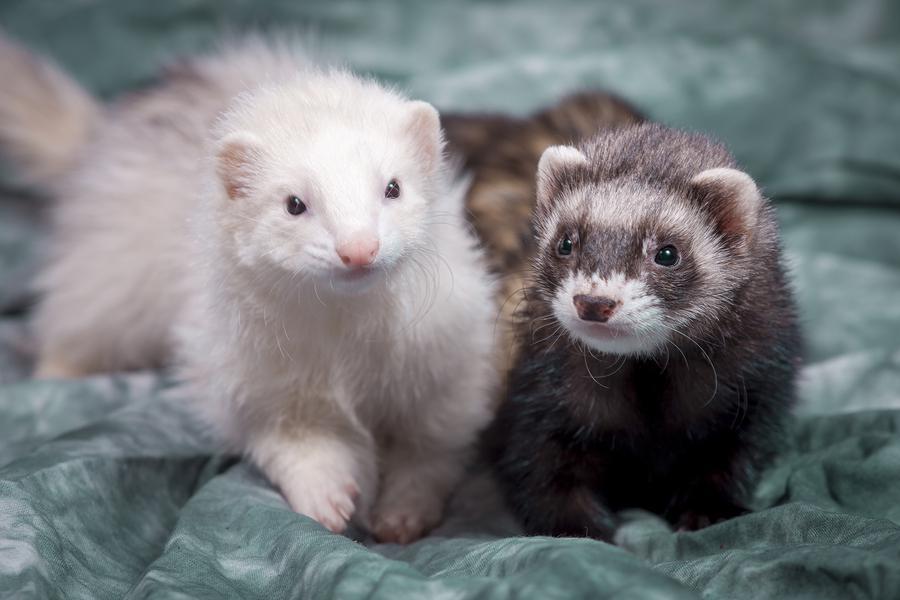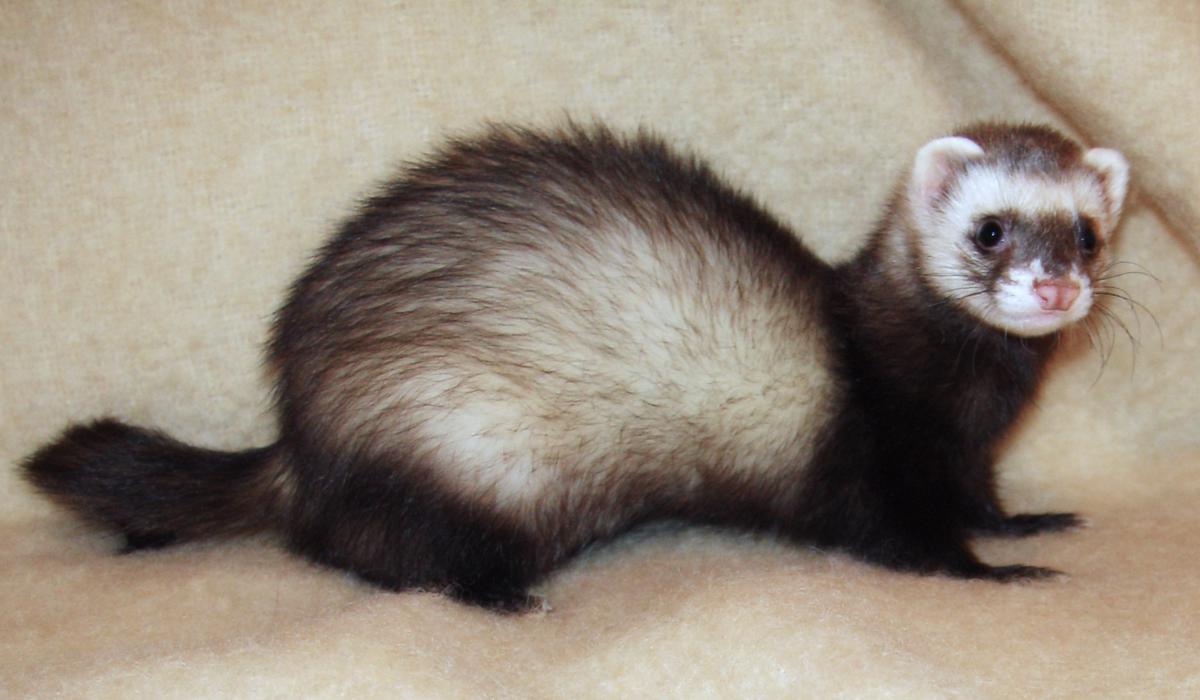The first image is the image on the left, the second image is the image on the right. Considering the images on both sides, is "There are exactly two ferrets in the image on the left." valid? Answer yes or no. Yes. 